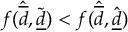Convert formula to latex. <formula><loc_0><loc_0><loc_500><loc_500>f ( \hat { \overline { d } } , \tilde { \underline { d } } ) < f ( \hat { \overline { d } } , \hat { \underline { d } } )</formula> 